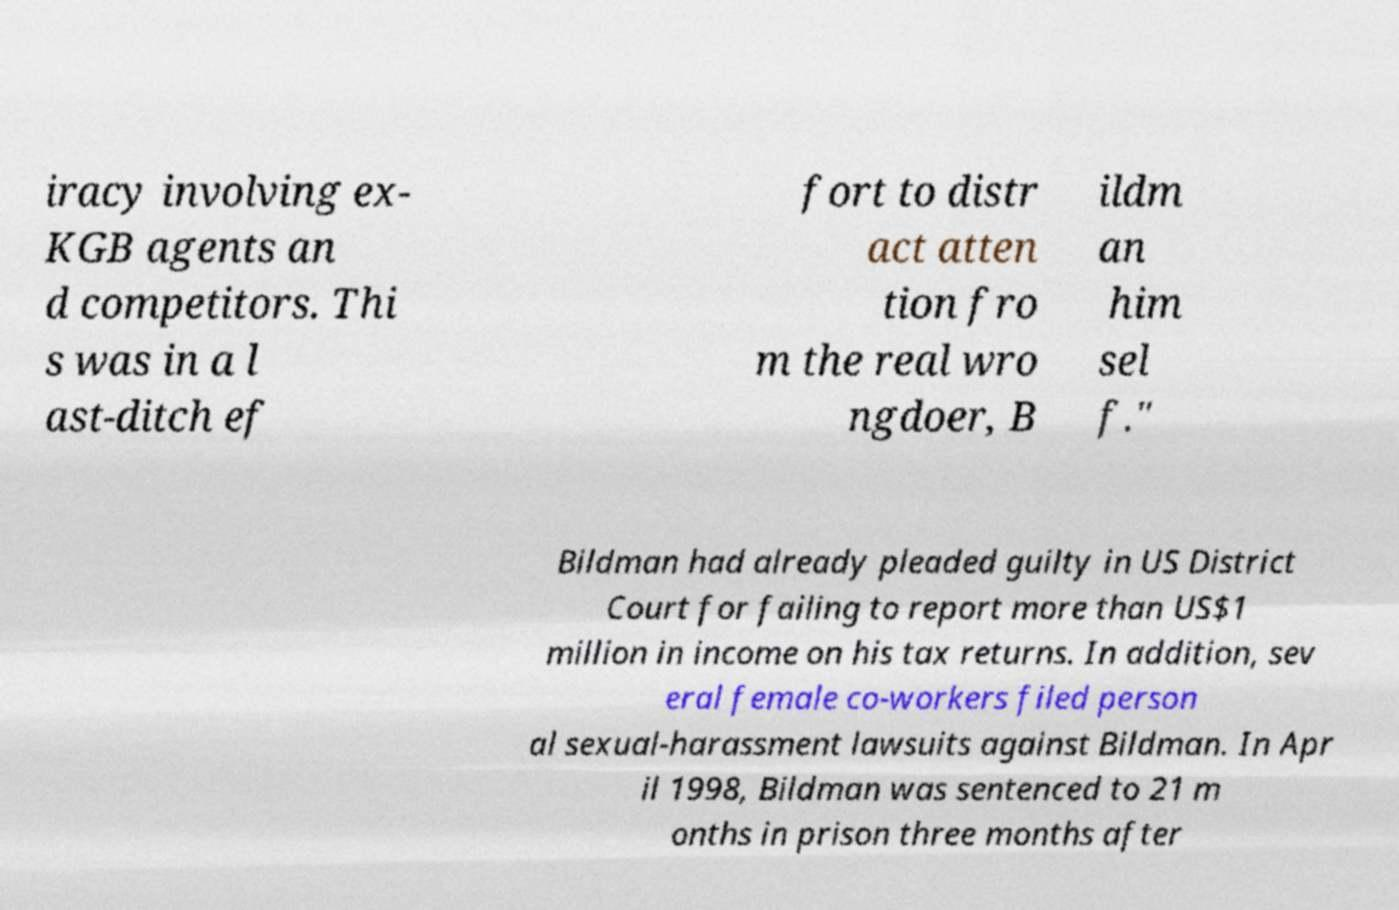What messages or text are displayed in this image? I need them in a readable, typed format. iracy involving ex- KGB agents an d competitors. Thi s was in a l ast-ditch ef fort to distr act atten tion fro m the real wro ngdoer, B ildm an him sel f." Bildman had already pleaded guilty in US District Court for failing to report more than US$1 million in income on his tax returns. In addition, sev eral female co-workers filed person al sexual-harassment lawsuits against Bildman. In Apr il 1998, Bildman was sentenced to 21 m onths in prison three months after 